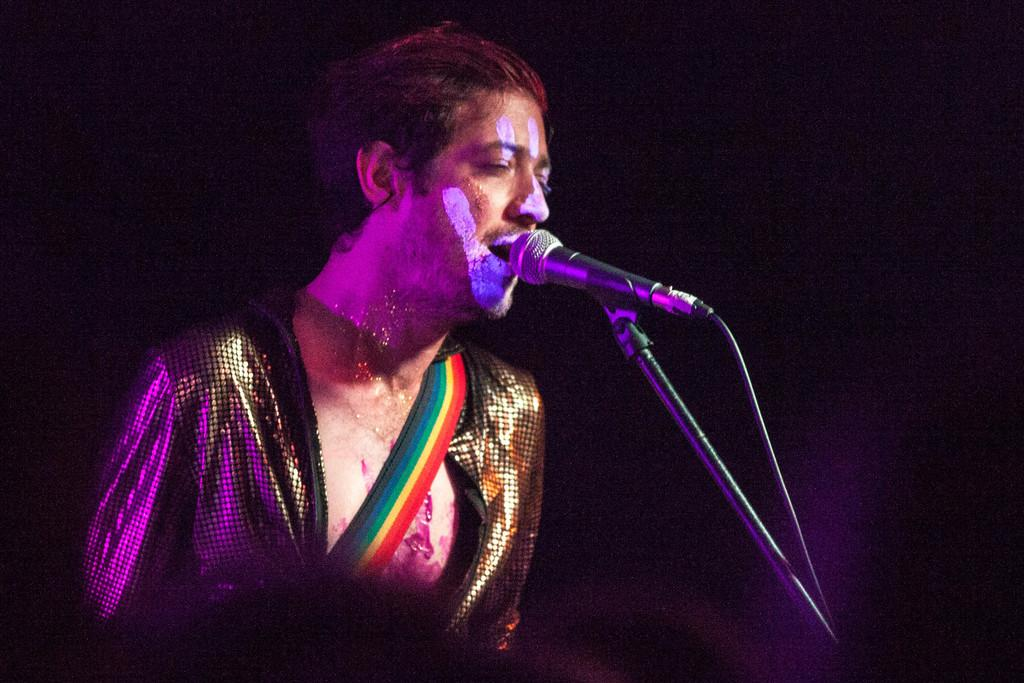What is the man in the image doing? The man is singing in the image. Can you describe any unique features of the man? Yes, there is a painting on the man's face. What can be seen on the right side of the image? There is a microphone on a stand on the right side of the image. How does the man plan to attack the line in the image? There is no mention of an attack or a line in the image. The man is singing, and there is a microphone on a stand on the right side of the image. 